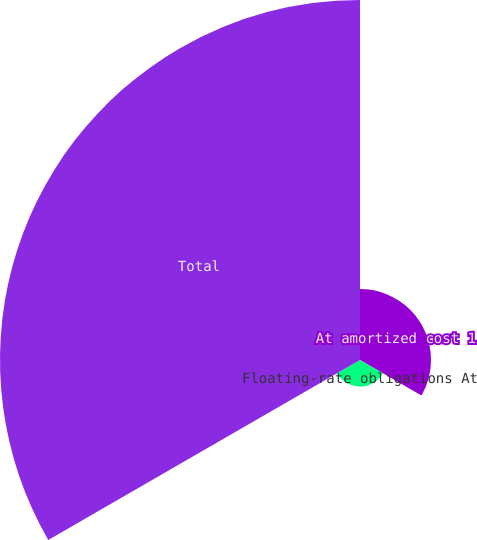Convert chart to OTSL. <chart><loc_0><loc_0><loc_500><loc_500><pie_chart><fcel>At amortized cost 1<fcel>Floating-rate obligations At<fcel>Total<nl><fcel>15.52%<fcel>5.8%<fcel>78.68%<nl></chart> 